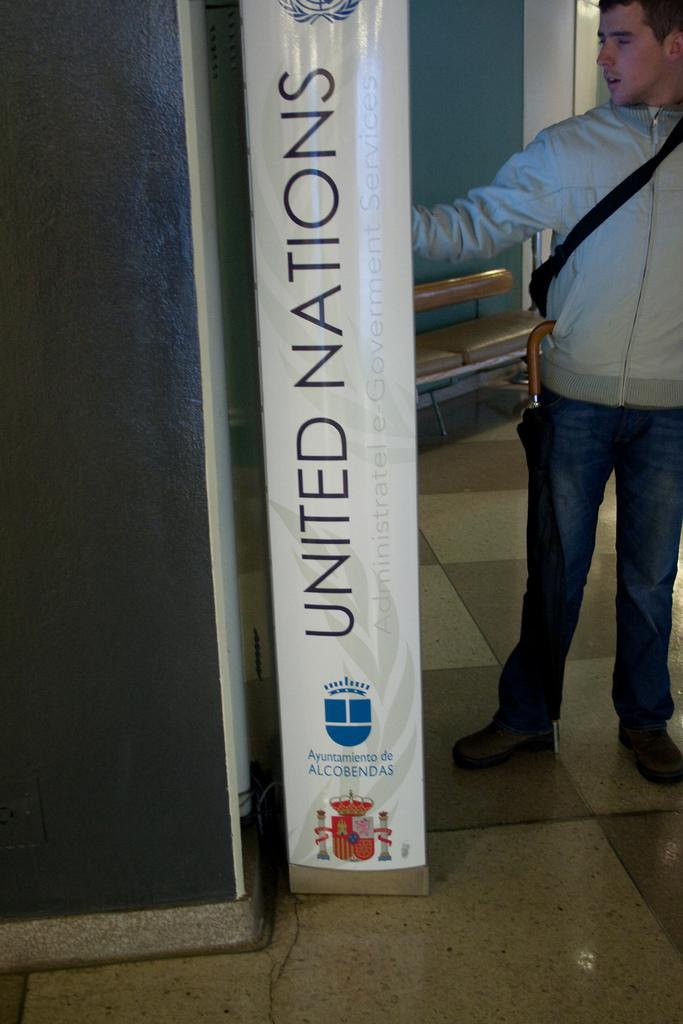Provide a one-sentence caption for the provided image. A person standing next to a large United Nations sign. 